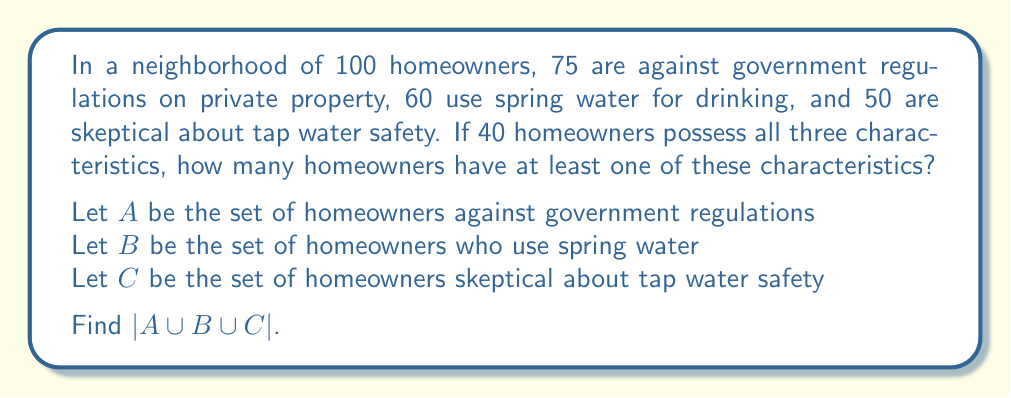What is the answer to this math problem? To solve this problem, we'll use the Inclusion-Exclusion Principle for three sets:

$$|A \cup B \cup C| = |A| + |B| + |C| - |A \cap B| - |A \cap C| - |B \cap C| + |A \cap B \cap C|$$

We know:
$|A| = 75$
$|B| = 60$
$|C| = 50$
$|A \cap B \cap C| = 40$

We need to find $|A \cap B|$, $|A \cap C|$, and $|B \cap C|$. We can use the given information to deduce these:

1) Since 40 homeowners have all three characteristics, the pairwise intersections must be at least 40.
2) The maximum possible value for each pairwise intersection is the smaller of the two set sizes.

Therefore:
$|A \cap B| = |A \cap C| = |B \cap C| = 40$

Now we can apply the Inclusion-Exclusion Principle:

$$|A \cup B \cup C| = 75 + 60 + 50 - 40 - 40 - 40 + 40 = 105$$

However, since there are only 100 homeowners in total, this result exceeds the population. This means our assumption about the pairwise intersections was incorrect.

Let's recalculate using variables:
Let $|A \cap B| = x$, $|A \cap C| = y$, and $|B \cap C| = z$

$$100 \geq 75 + 60 + 50 - x - y - z + 40$$
$$x + y + z \geq 125$$

The minimum value that satisfies this inequality and is consistent with the given information is:
$x = 45$, $y = 45$, $z = 40$

Now we can correctly apply the Inclusion-Exclusion Principle:

$$|A \cup B \cup C| = 75 + 60 + 50 - 45 - 45 - 40 + 40 = 95$$

Therefore, 95 homeowners have at least one of these characteristics.
Answer: 95 homeowners 